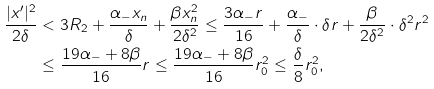Convert formula to latex. <formula><loc_0><loc_0><loc_500><loc_500>\frac { | x ^ { \prime } | ^ { 2 } } { 2 \delta } & < 3 R _ { 2 } + \frac { \alpha _ { - } x _ { n } } { \delta } + \frac { \beta x _ { n } ^ { 2 } } { 2 \delta ^ { 2 } } \leq \frac { 3 \alpha _ { - } r } { 1 6 } + \frac { \alpha _ { - } } { \delta } \cdot \delta r + \frac { \beta } { 2 \delta ^ { 2 } } \cdot \delta ^ { 2 } r ^ { 2 } \\ & \leq \frac { 1 9 \alpha _ { - } + 8 \beta } { 1 6 } r \leq \frac { 1 9 \alpha _ { - } + 8 \beta } { 1 6 } r _ { 0 } ^ { 2 } \leq \frac { \delta } { 8 } r _ { 0 } ^ { 2 } ,</formula> 